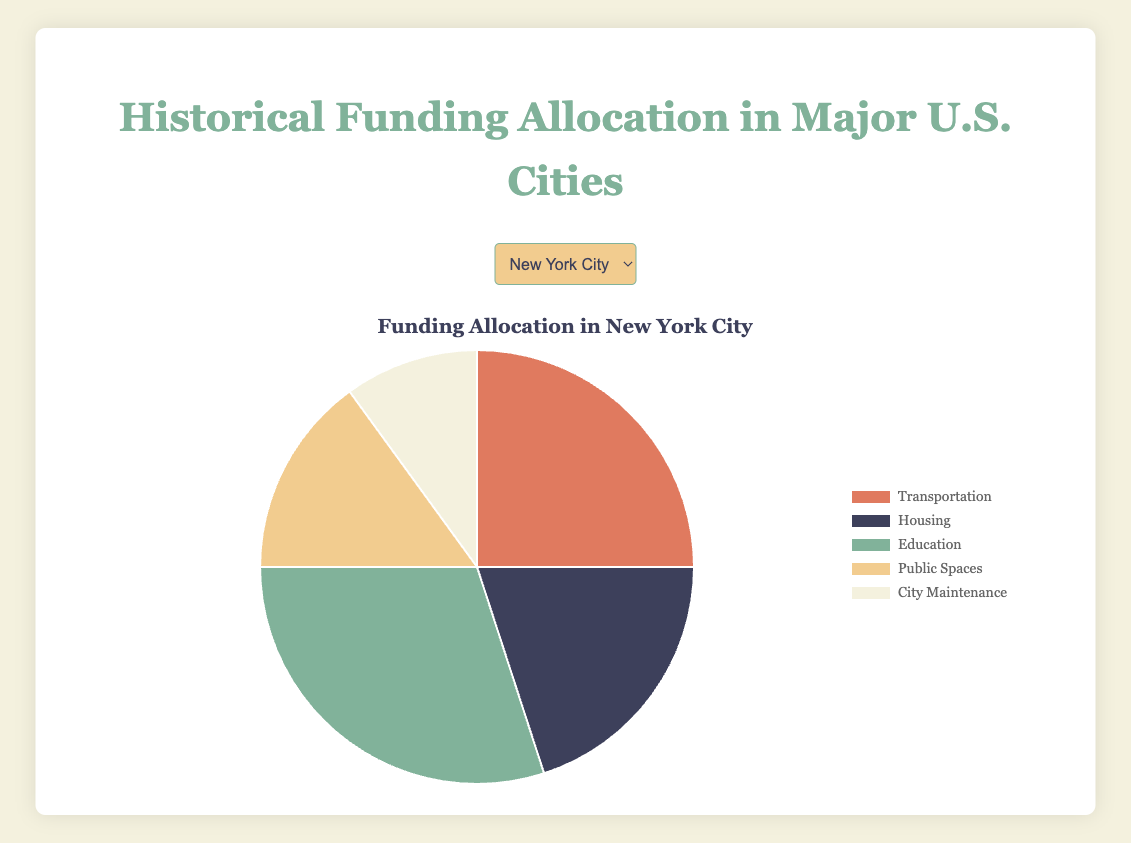What is the total amount allocated to Education across all cities? Sum the allocation for Education in each city: 180,000,000 (New York City) + 160,000,000 (Los Angeles) + 140,000,000 (Chicago) + 120,000,000 (Houston) + 100,000,000 (Phoenix) + 110,000,000 (Philadelphia) + 95,000,000 (San Antonio) + 90,000,000 (San Diego) + 98,000,000 (Dallas) + 87,000,000 (San Jose). The result is 1,180,000,000.
Answer: 1,180,000,000 Which city has the highest allocation for Public Spaces? Compare the Public Spaces allocation for each city: 90,000,000 (New York City), 70,000,000 (Los Angeles), 80,000,000 (Chicago), 65,000,000 (Houston), 60,000,000 (Phoenix), 70,000,000 (Philadelphia), 60,000,000 (San Antonio), 55,000,000 (San Diego), 60,000,000 (Dallas), 53,000,000 (San Jose). New York City has the highest allocation for Public Spaces.
Answer: New York City How does the allocation for Transportation in Chicago compare to that in Houston? Chicago's allocation for Transportation is 100,000,000, while Houston's is 90,000,000. Compare the two amounts to see that Chicago's allocation is greater by 10,000,000.
Answer: Chicago's allocation is 10,000,000 greater than Houston's What percentage of New York City's total funding is allocated to Housing? First, calculate New York City's total funding: 150,000,000 (Transportation) + 120,000,000 (Housing) + 180,000,000 (Education) + 90,000,000 (Public Spaces) + 60,000,000 (City Maintenance) = 600,000,000. Then, find the percentage allocated to Housing: (120,000,000 / 600,000,000) * 100 = 20%.
Answer: 20% Which sector has the smallest allocation in Los Angeles? Look at the values for Los Angeles: Transportation (130,000,000), Housing (110,000,000), Education (160,000,000), Public Spaces (70,000,000), City Maintenance (50,000,000). City Maintenance has the smallest allocation.
Answer: City Maintenance If we combine the funds allocated for Housing and City Maintenance in Dallas, what is the total? Add the amounts allocated for Housing (72,000,000) and City Maintenance (40,000,000) in Dallas. The result is 112,000,000.
Answer: 112,000,000 What is the average funding for Transportation across all cities? Sum the allocations for Transportation in each city: 150,000,000 (New York City) + 130,000,000 (Los Angeles) + 100,000,000 (Chicago) + 90,000,000 (Houston) + 80,000,000 (Phoenix) + 95,000,000 (Philadelphia) + 85,000,000 (San Antonio) + 80,000,000 (San Diego) + 88,000,000 (Dallas) + 78,000,000 (San Jose) = 976,000,000. Divide by the number of cities (10). The average is 97,600,000.
Answer: 97,600,000 